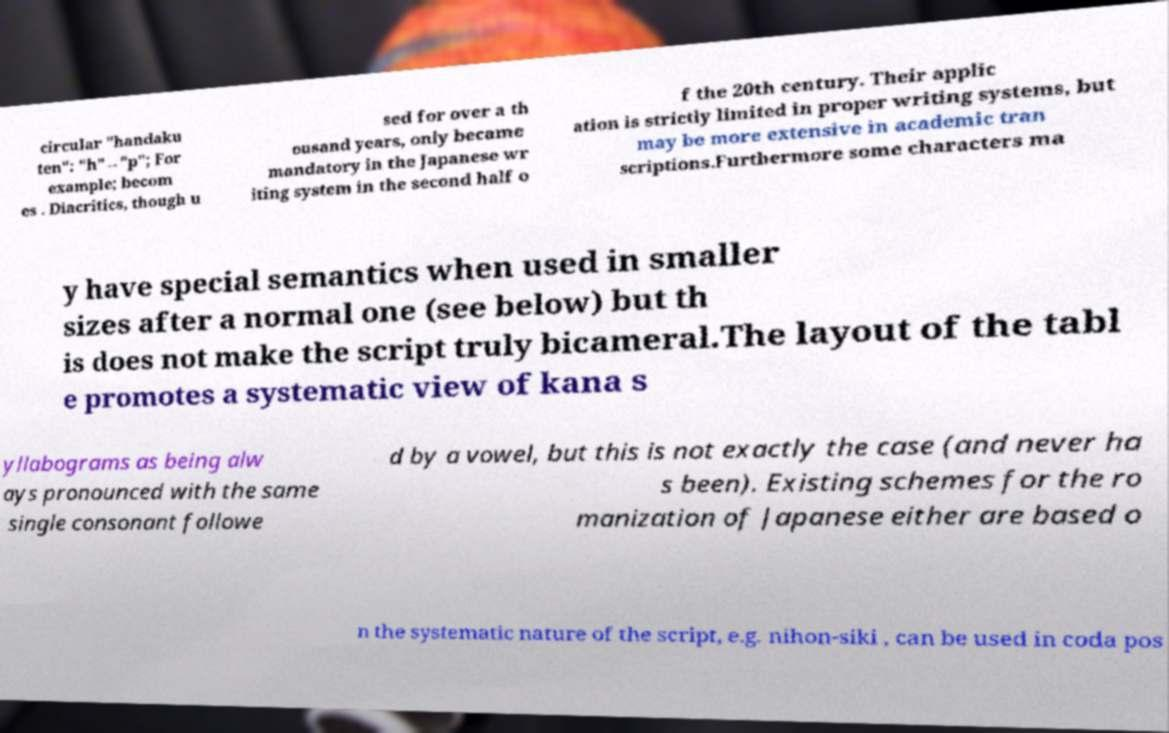Could you assist in decoding the text presented in this image and type it out clearly? circular "handaku ten": "h"→"p"; For example; becom es . Diacritics, though u sed for over a th ousand years, only became mandatory in the Japanese wr iting system in the second half o f the 20th century. Their applic ation is strictly limited in proper writing systems, but may be more extensive in academic tran scriptions.Furthermore some characters ma y have special semantics when used in smaller sizes after a normal one (see below) but th is does not make the script truly bicameral.The layout of the tabl e promotes a systematic view of kana s yllabograms as being alw ays pronounced with the same single consonant followe d by a vowel, but this is not exactly the case (and never ha s been). Existing schemes for the ro manization of Japanese either are based o n the systematic nature of the script, e.g. nihon-siki , can be used in coda pos 